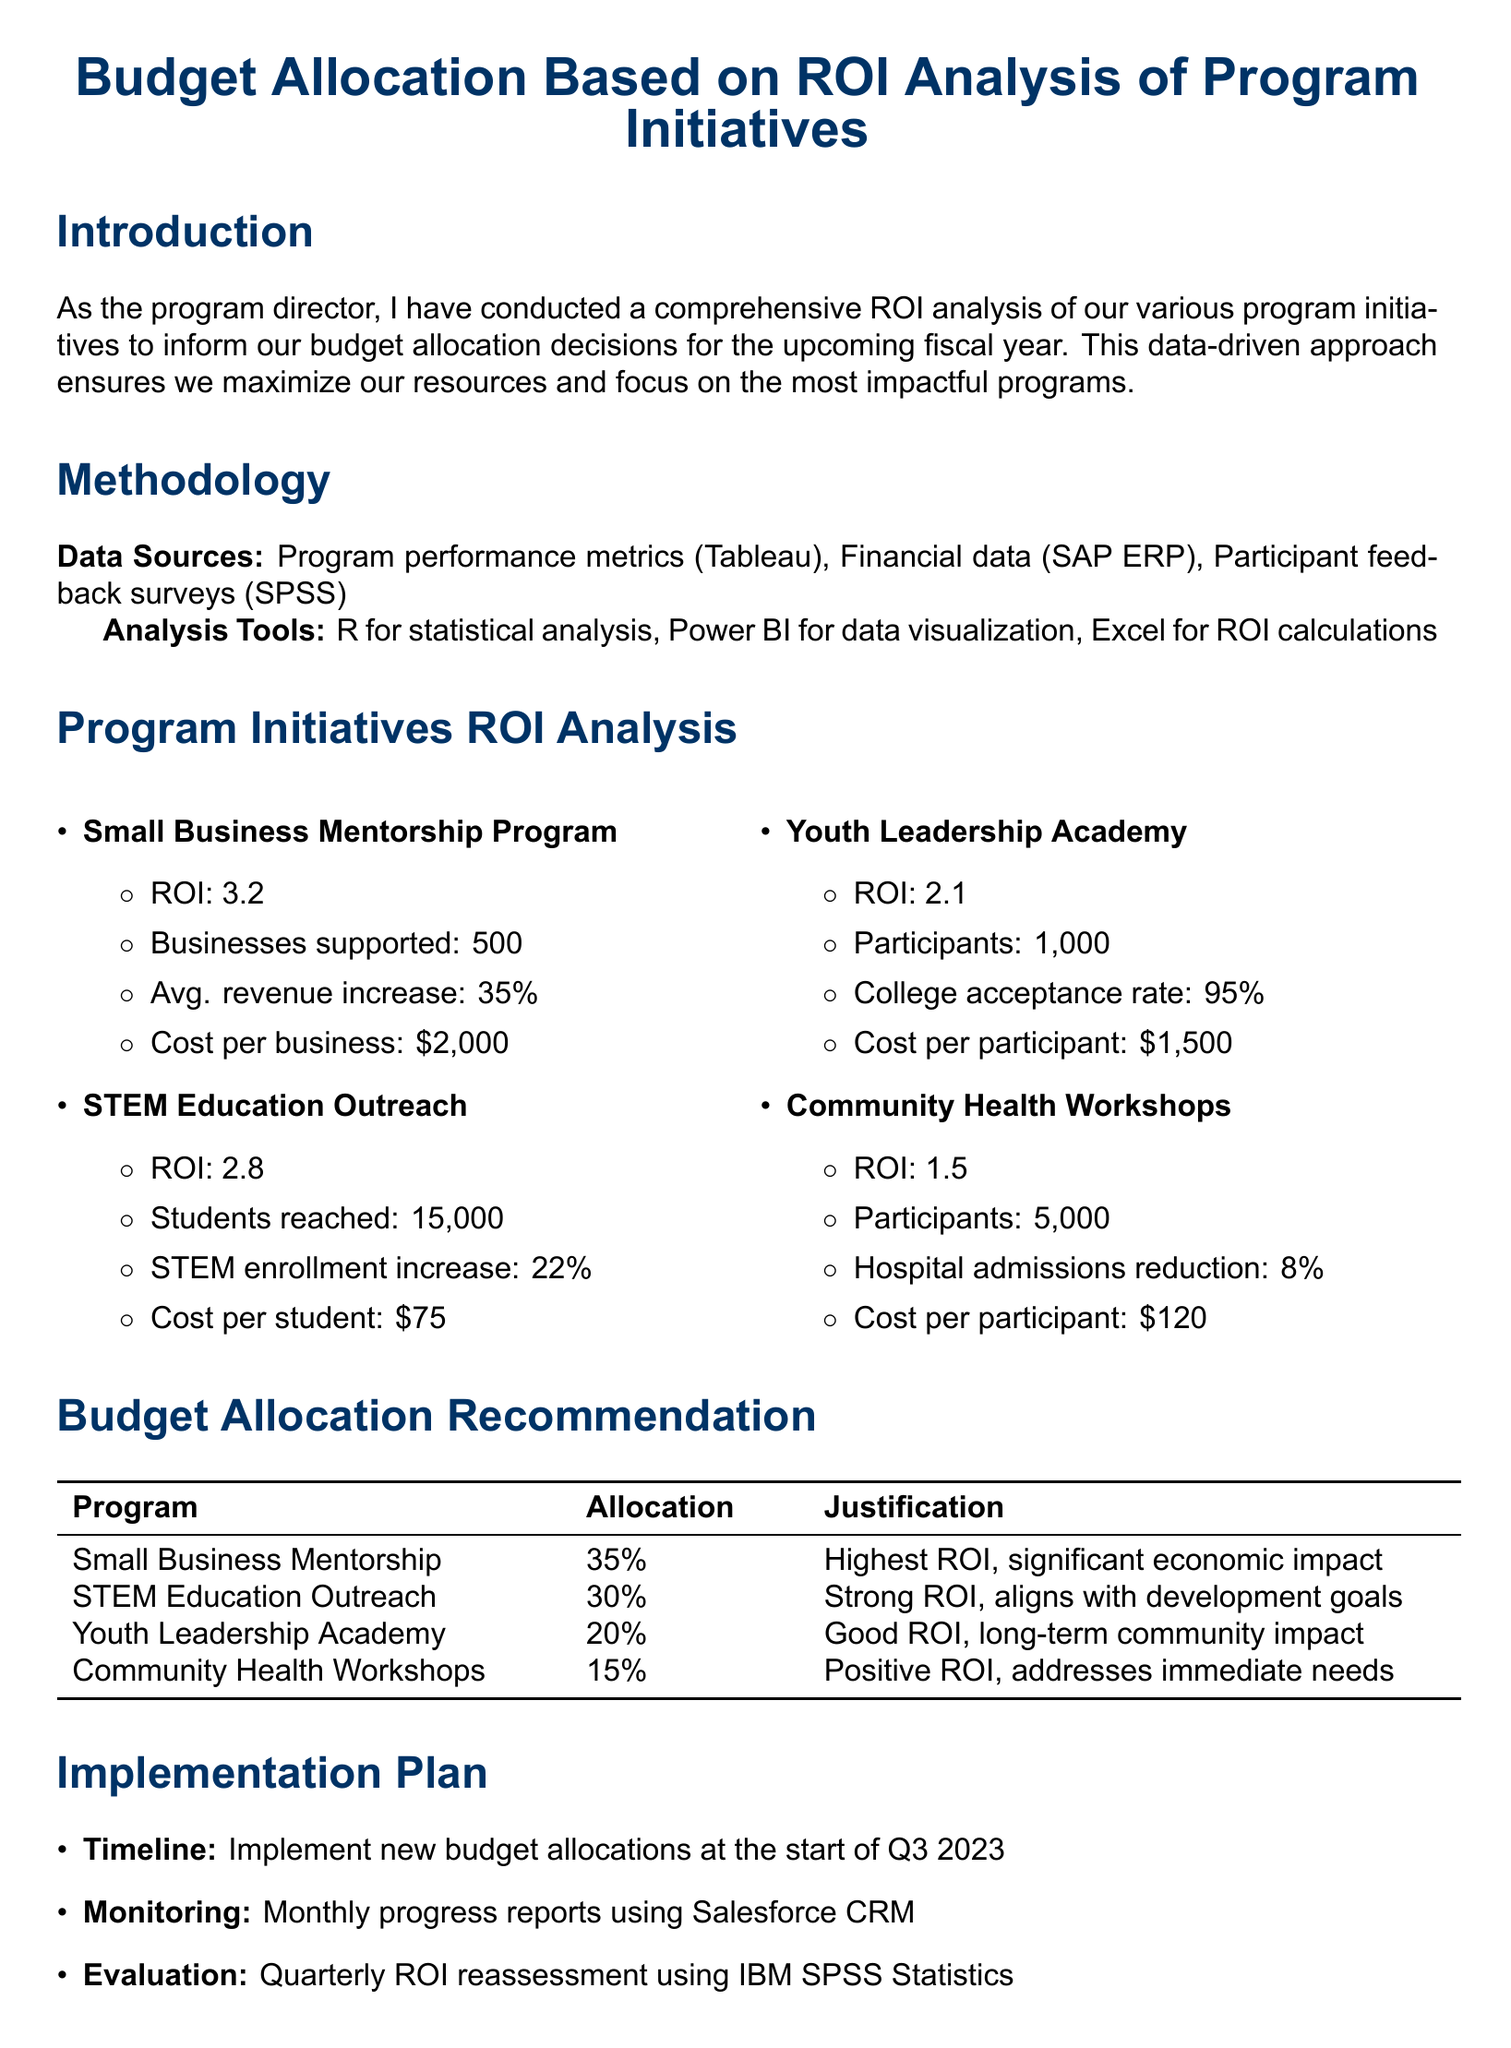What is the total number of businesses supported by the Small Business Mentorship Program? The document states that the Small Business Mentorship Program supported 500 businesses.
Answer: 500 What is the ROI of the STEM Education Outreach program? The document lists the ROI of the STEM Education Outreach program as 2.8.
Answer: 2.8 Which program has the highest budget allocation percentage? According to the budget allocation recommendation section, the Small Business Mentorship Program has the highest allocation percentage at 35%.
Answer: Small Business Mentorship Program What is the cost per participant for the Community Health Workshops? The document indicates that the cost per participant for the Community Health Workshops is $120.
Answer: $120 What is the timeline for the implementation of the new budget allocations? The document specifies that the new budget allocations will be implemented at the start of Q3 2023.
Answer: Start of Q3 2023 Which program aligns with long-term community development goals? The document describes the STEM Education Outreach program as aligning with long-term community development goals.
Answer: STEM Education Outreach What is the reduction percentage in local hospital admissions due to the Community Health Workshops? The document states that the Community Health Workshops resulted in an 8% reduction in local hospital admissions.
Answer: 8% What method will be used for quarterly ROI reassessment? The document mentions that IBM SPSS Statistics will be used for quarterly ROI reassessment.
Answer: IBM SPSS Statistics 